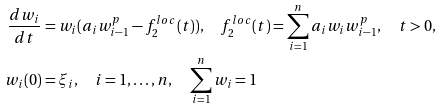<formula> <loc_0><loc_0><loc_500><loc_500>\frac { d w _ { i } } { d t } & = w _ { i } ( a _ { i } w _ { i - 1 } ^ { p } - f _ { 2 } ^ { l o c } ( t ) ) , \quad f _ { 2 } ^ { l o c } ( t ) = \sum _ { i = 1 } ^ { n } a _ { i } w _ { i } w _ { i - 1 } ^ { p } , \quad t > 0 , \\ w _ { i } ( 0 ) & = \xi _ { i } , \quad i = 1 , \dots , n , \quad \sum _ { i = 1 } ^ { n } w _ { i } = 1</formula> 